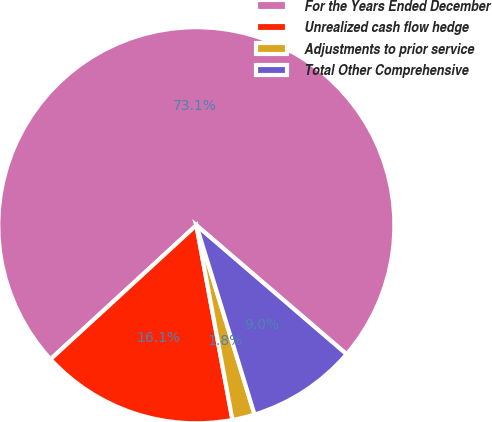Convert chart to OTSL. <chart><loc_0><loc_0><loc_500><loc_500><pie_chart><fcel>For the Years Ended December<fcel>Unrealized cash flow hedge<fcel>Adjustments to prior service<fcel>Total Other Comprehensive<nl><fcel>73.13%<fcel>16.09%<fcel>1.83%<fcel>8.96%<nl></chart> 